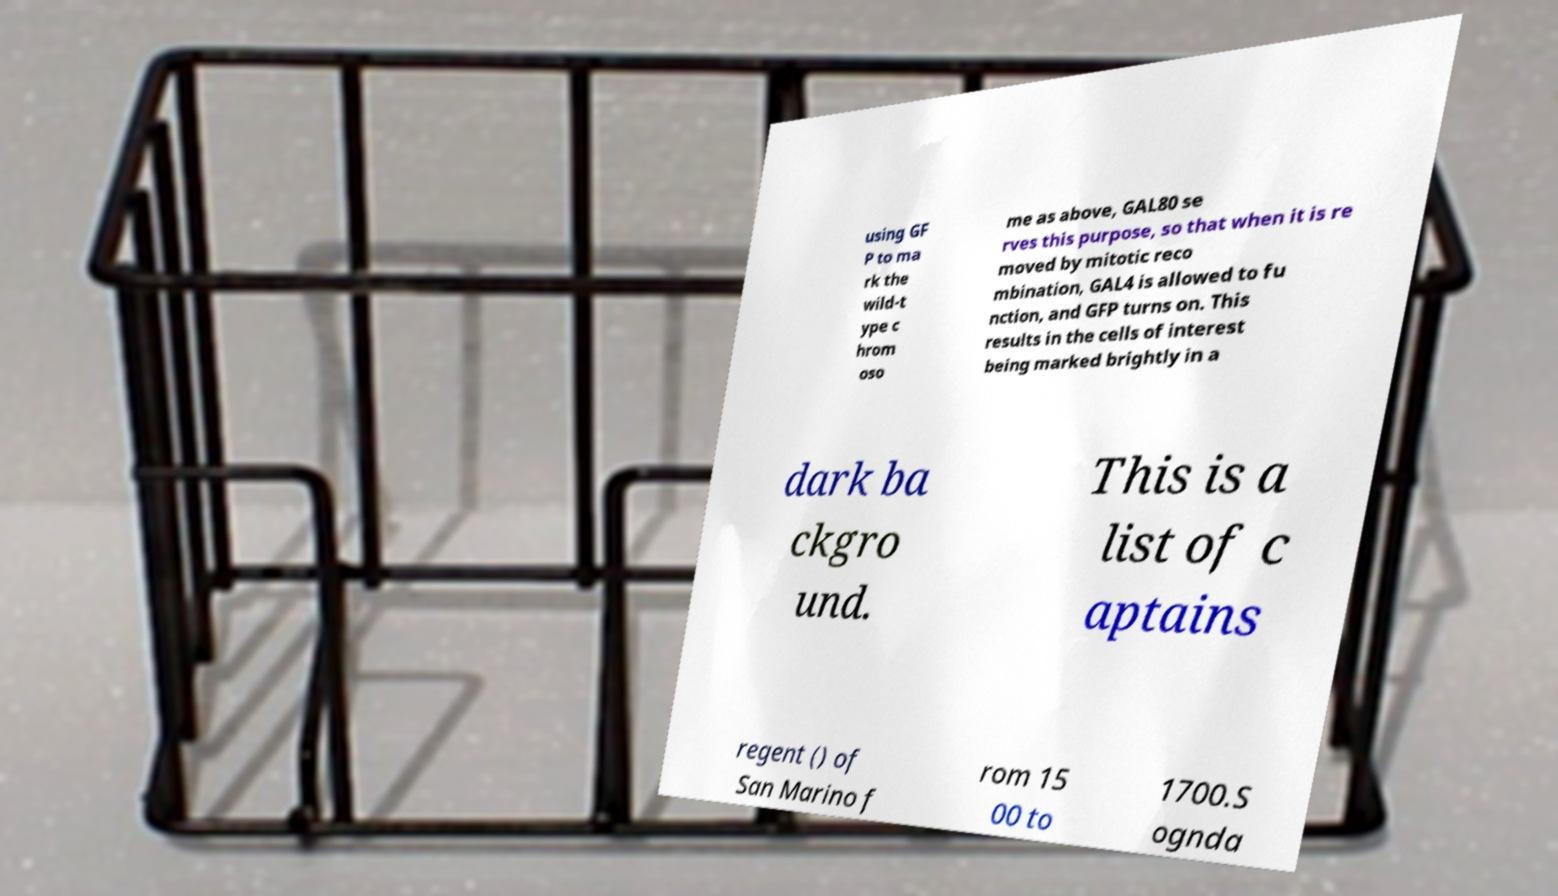Can you read and provide the text displayed in the image?This photo seems to have some interesting text. Can you extract and type it out for me? using GF P to ma rk the wild-t ype c hrom oso me as above, GAL80 se rves this purpose, so that when it is re moved by mitotic reco mbination, GAL4 is allowed to fu nction, and GFP turns on. This results in the cells of interest being marked brightly in a dark ba ckgro und. This is a list of c aptains regent () of San Marino f rom 15 00 to 1700.S ognda 